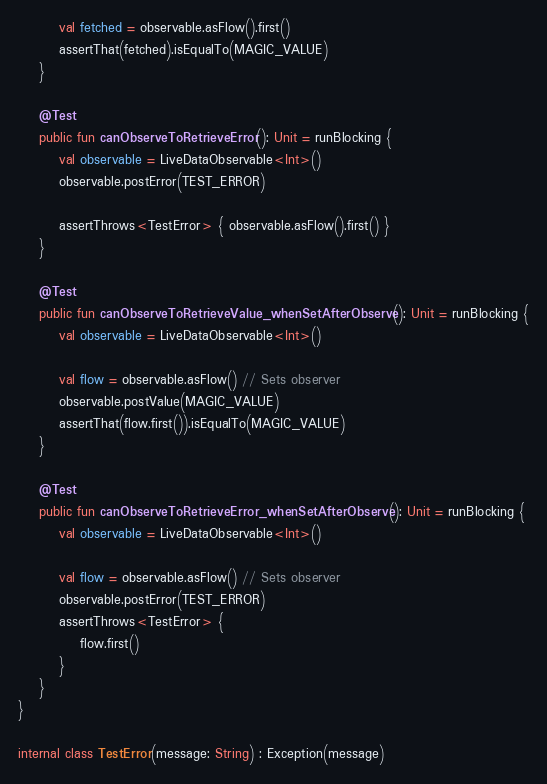<code> <loc_0><loc_0><loc_500><loc_500><_Kotlin_>        val fetched = observable.asFlow().first()
        assertThat(fetched).isEqualTo(MAGIC_VALUE)
    }

    @Test
    public fun canObserveToRetrieveError(): Unit = runBlocking {
        val observable = LiveDataObservable<Int>()
        observable.postError(TEST_ERROR)

        assertThrows<TestError> { observable.asFlow().first() }
    }

    @Test
    public fun canObserveToRetrieveValue_whenSetAfterObserve(): Unit = runBlocking {
        val observable = LiveDataObservable<Int>()

        val flow = observable.asFlow() // Sets observer
        observable.postValue(MAGIC_VALUE)
        assertThat(flow.first()).isEqualTo(MAGIC_VALUE)
    }

    @Test
    public fun canObserveToRetrieveError_whenSetAfterObserve(): Unit = runBlocking {
        val observable = LiveDataObservable<Int>()

        val flow = observable.asFlow() // Sets observer
        observable.postError(TEST_ERROR)
        assertThrows<TestError> {
            flow.first()
        }
    }
}

internal class TestError(message: String) : Exception(message)</code> 